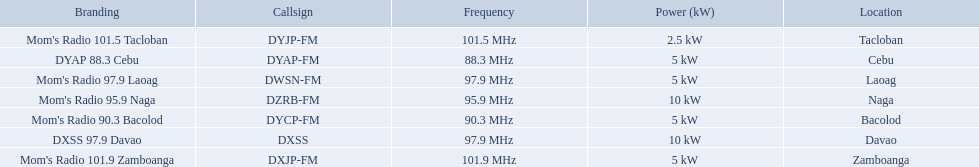Which stations broadcast in dyap-fm? Mom's Radio 97.9 Laoag, Mom's Radio 95.9 Naga, Mom's Radio 90.3 Bacolod, DYAP 88.3 Cebu, Mom's Radio 101.5 Tacloban, Mom's Radio 101.9 Zamboanga, DXSS 97.9 Davao. Of those stations which broadcast in dyap-fm, which stations broadcast with 5kw of power or under? Mom's Radio 97.9 Laoag, Mom's Radio 90.3 Bacolod, DYAP 88.3 Cebu, Mom's Radio 101.5 Tacloban, Mom's Radio 101.9 Zamboanga. Of those stations that broadcast with 5kw of power or under, which broadcasts with the least power? Mom's Radio 101.5 Tacloban. 